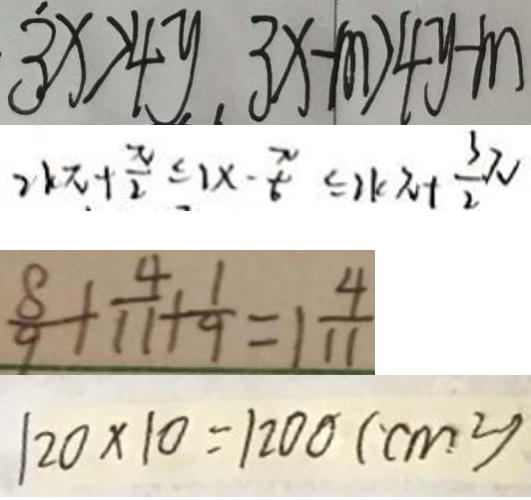<formula> <loc_0><loc_0><loc_500><loc_500>3 x > 4 y , 3 x - m > 4 y - m 
 2 k \pi + \frac { \pi } { 2 } \leq 1 x - \frac { \pi } { 6 } \leq 2 k \pi + \frac { 3 } { 2 } \pi 
 \frac { 8 } { 9 } + \frac { 4 } { 1 1 } + \frac { 1 } { 9 } = 1 \frac { 4 } { 1 1 } 
 1 2 0 \times 1 0 = 1 2 0 0 ( c m ^ { 2 } )</formula> 